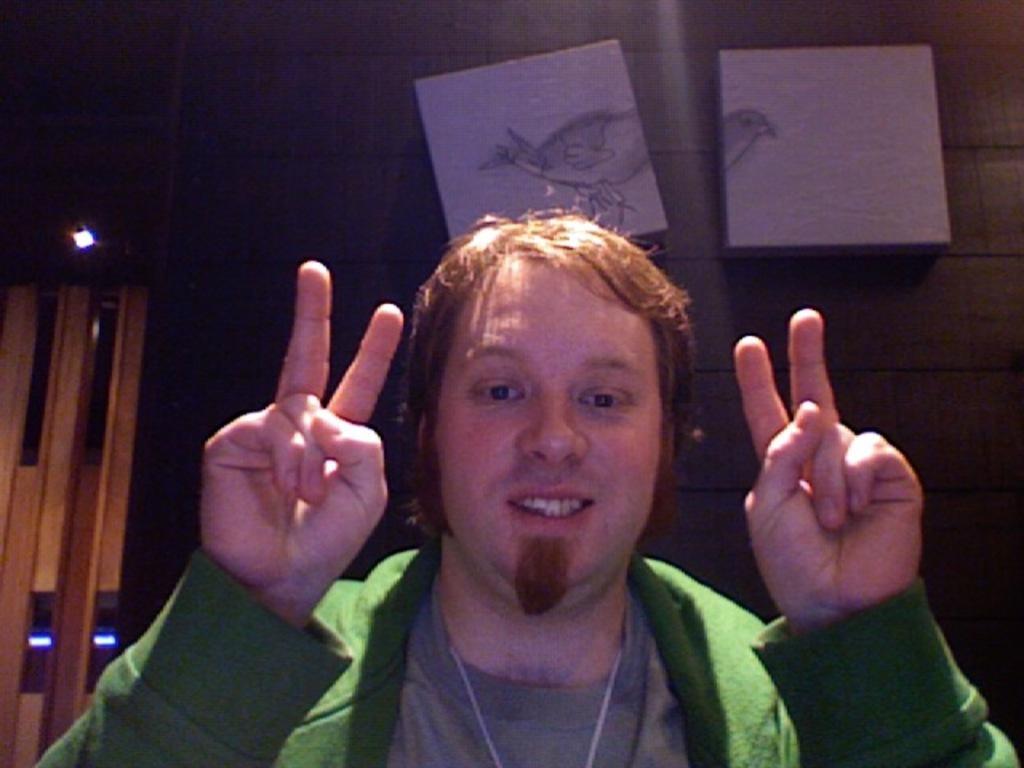Could you give a brief overview of what you see in this image? In this image we can see a person. There are few objects on the wall. There are few lights at the left side of the image. 